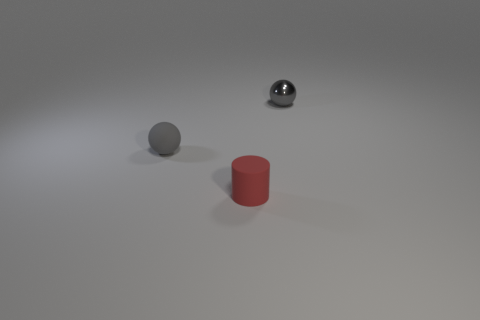Add 3 brown metal spheres. How many objects exist? 6 Subtract all spheres. How many objects are left? 1 Subtract 0 blue cylinders. How many objects are left? 3 Subtract all small matte things. Subtract all big cyan shiny cylinders. How many objects are left? 1 Add 2 tiny red objects. How many tiny red objects are left? 3 Add 2 small red cylinders. How many small red cylinders exist? 3 